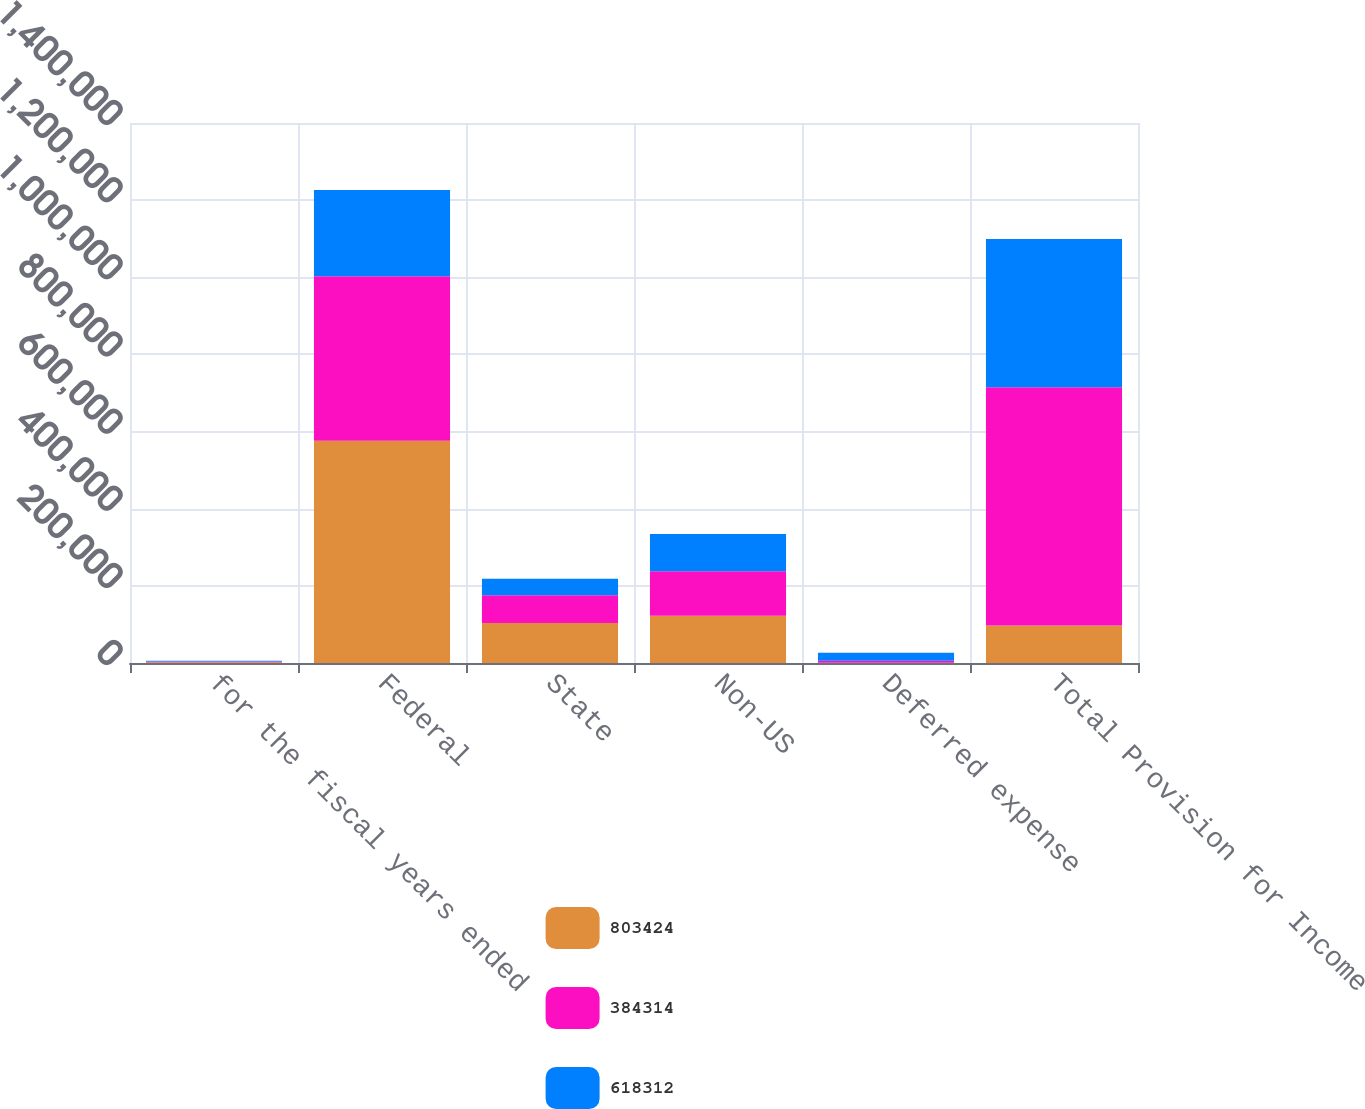<chart> <loc_0><loc_0><loc_500><loc_500><stacked_bar_chart><ecel><fcel>for the fiscal years ended<fcel>Federal<fcel>State<fcel>Non-US<fcel>Deferred expense<fcel>Total Provision for Income<nl><fcel>803424<fcel>2011<fcel>576418<fcel>103791<fcel>122801<fcel>414<fcel>96901<nl><fcel>384314<fcel>2010<fcel>426470<fcel>71545<fcel>115033<fcel>5264<fcel>618312<nl><fcel>618312<fcel>2009<fcel>223600<fcel>42855<fcel>96901<fcel>20958<fcel>384314<nl></chart> 